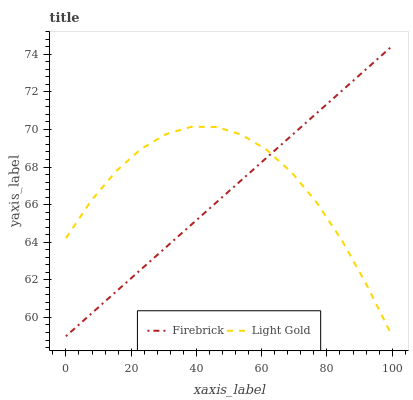Does Firebrick have the minimum area under the curve?
Answer yes or no. Yes. Does Light Gold have the maximum area under the curve?
Answer yes or no. Yes. Does Light Gold have the minimum area under the curve?
Answer yes or no. No. Is Firebrick the smoothest?
Answer yes or no. Yes. Is Light Gold the roughest?
Answer yes or no. Yes. Is Light Gold the smoothest?
Answer yes or no. No. Does Firebrick have the lowest value?
Answer yes or no. Yes. Does Firebrick have the highest value?
Answer yes or no. Yes. Does Light Gold have the highest value?
Answer yes or no. No. Does Light Gold intersect Firebrick?
Answer yes or no. Yes. Is Light Gold less than Firebrick?
Answer yes or no. No. Is Light Gold greater than Firebrick?
Answer yes or no. No. 